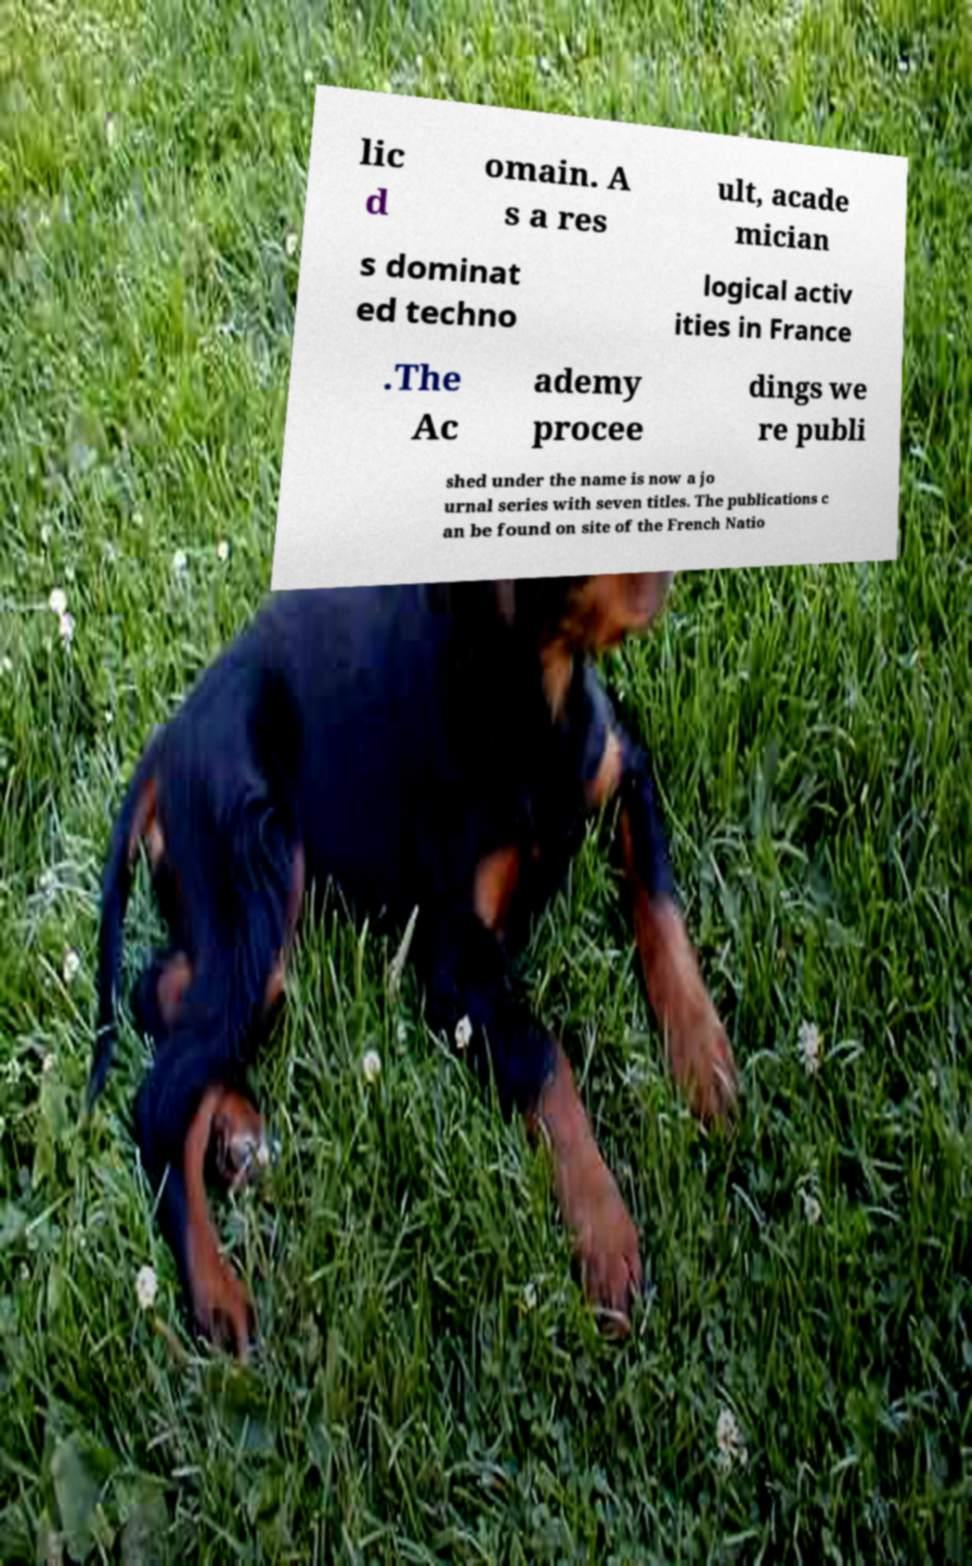Please read and relay the text visible in this image. What does it say? lic d omain. A s a res ult, acade mician s dominat ed techno logical activ ities in France .The Ac ademy procee dings we re publi shed under the name is now a jo urnal series with seven titles. The publications c an be found on site of the French Natio 